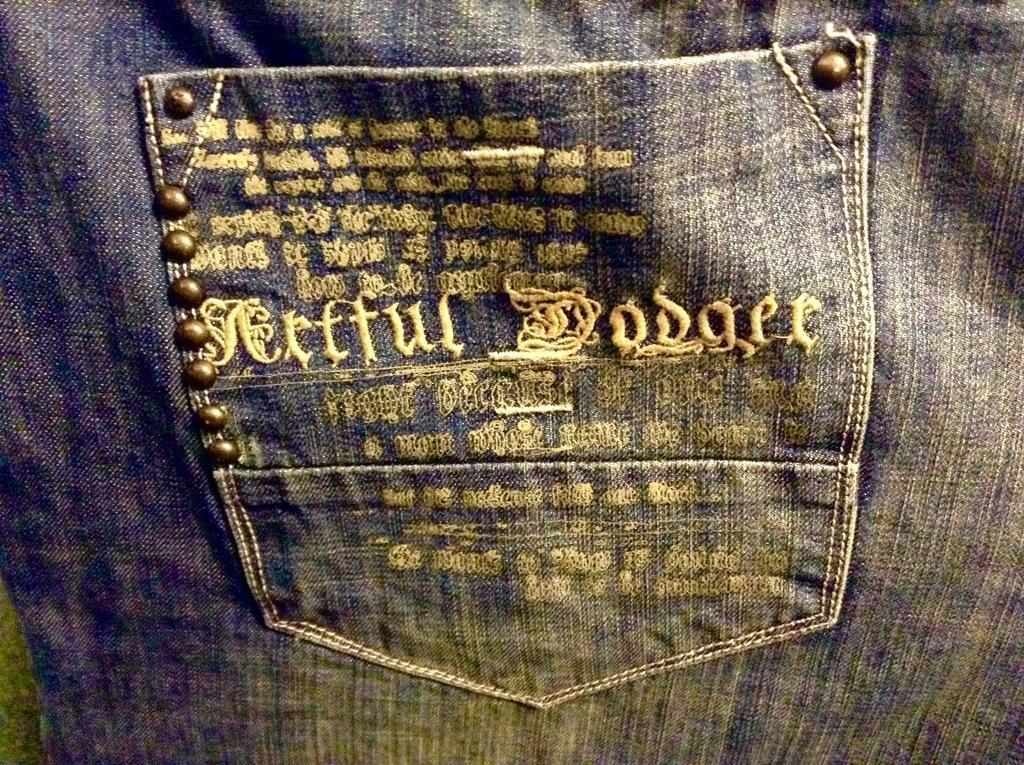How would you summarize this image in a sentence or two? In this image we can see the pocket a jeans pant. On the pocket there is some text and some buttons. 